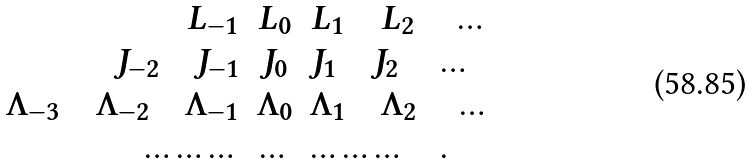Convert formula to latex. <formula><loc_0><loc_0><loc_500><loc_500>\begin{array} { r c l } L _ { - 1 } & L _ { 0 } & L _ { 1 } \quad L _ { 2 } \quad \dots \\ J _ { - 2 } \quad J _ { - 1 } & J _ { 0 } & J _ { 1 } \quad J _ { 2 } \quad \dots \\ \Lambda _ { - 3 } \quad \Lambda _ { - 2 } \quad \Lambda _ { - 1 } & \Lambda _ { 0 } & \Lambda _ { 1 } \quad \Lambda _ { 2 } \quad \dots \\ \dots \dots \dots & \dots & \dots \dots \dots \quad . \end{array}</formula> 